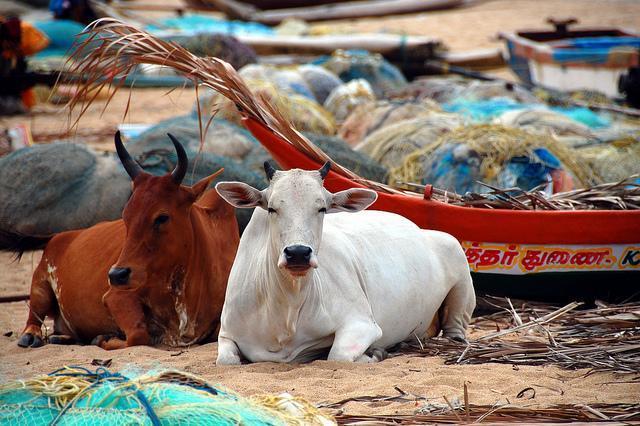How many horns are visible?
Give a very brief answer. 4. How many boats are there?
Give a very brief answer. 3. How many cows are in the picture?
Give a very brief answer. 2. 